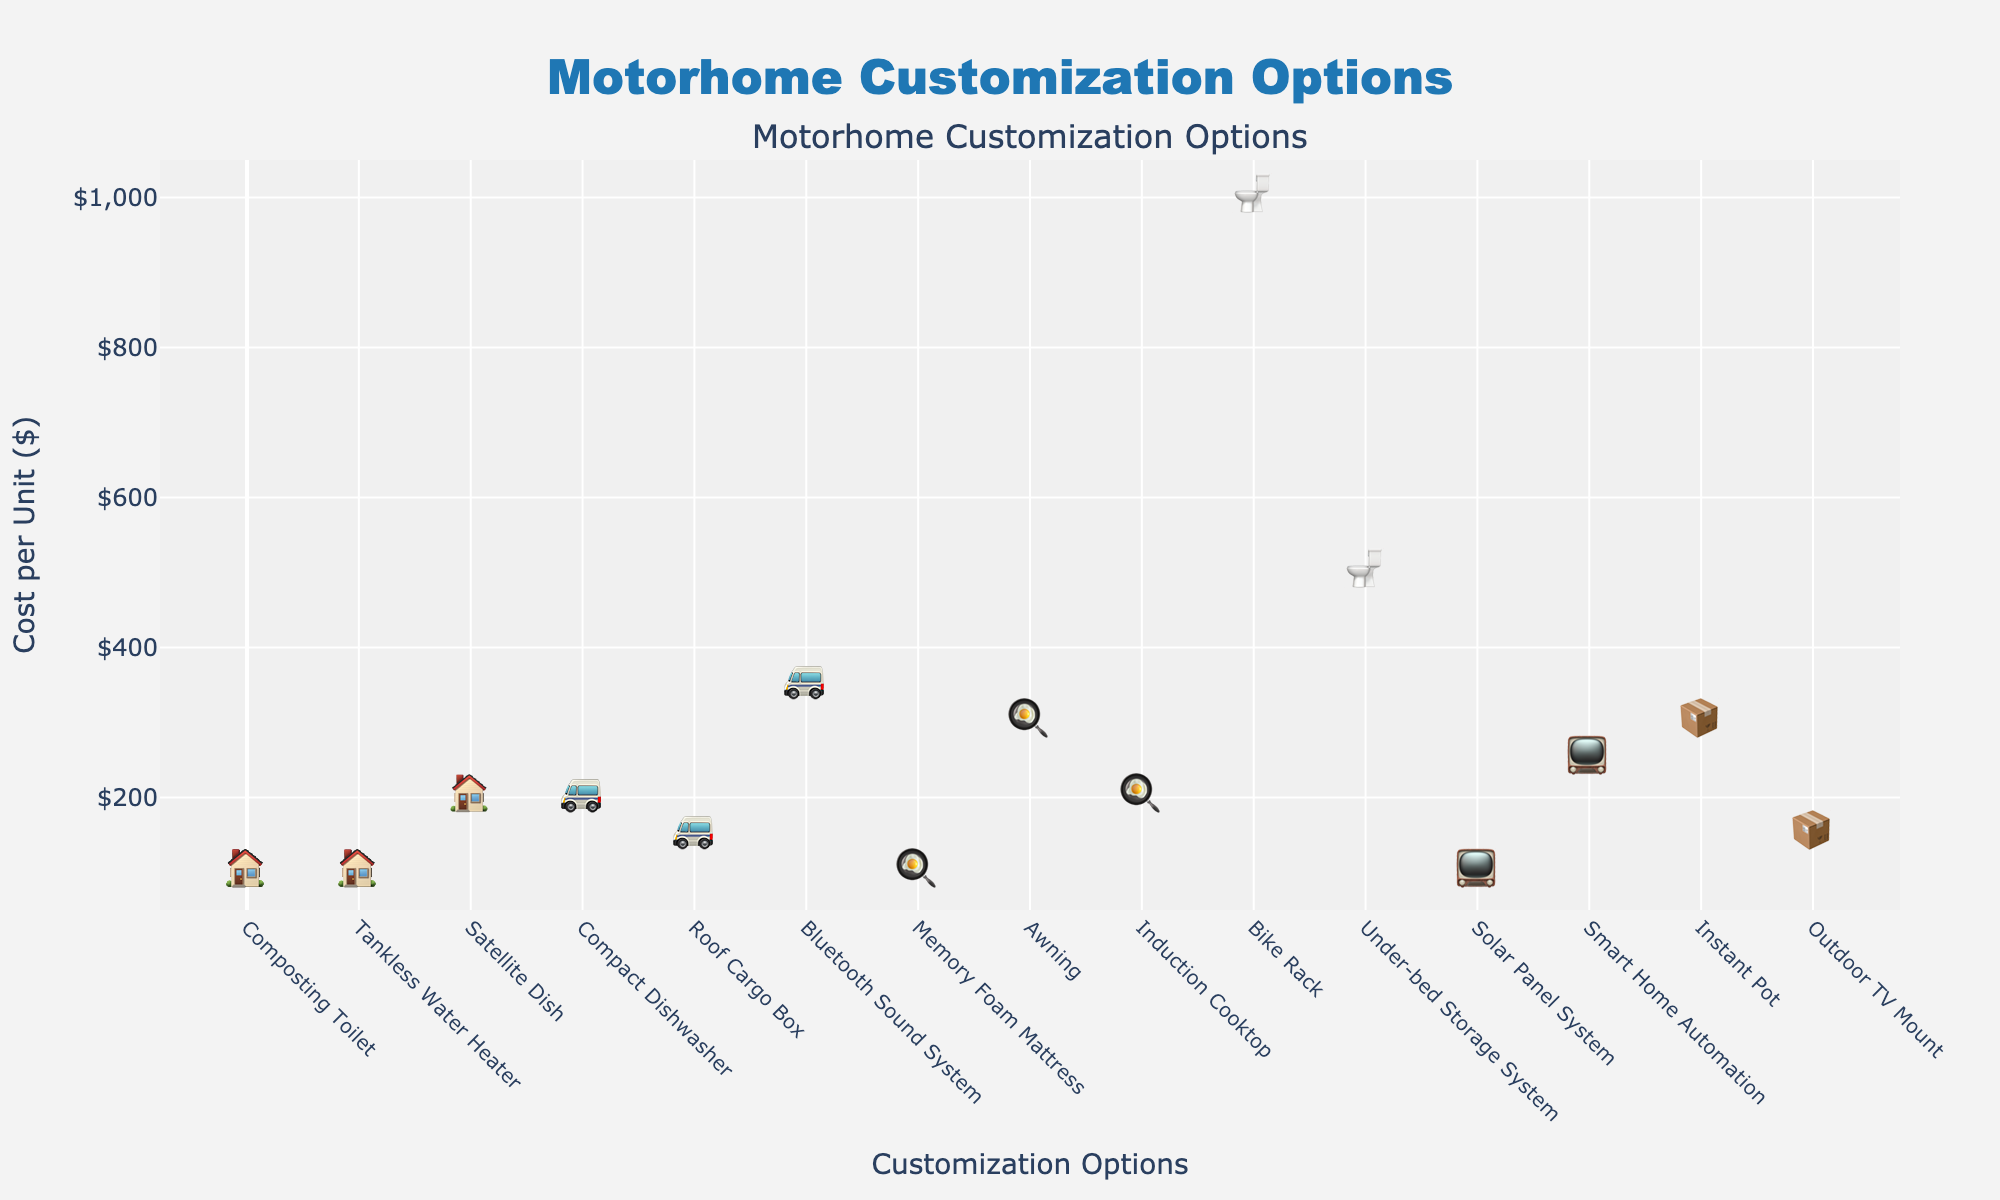Which customization option has the highest cost per unit? The highest cost per unit can be found by looking for the highest point on the y-axis, which represents cost per unit.
Answer: Composting Toilet What is the total cost of all Interior customizations? The total cost is obtained by summing the costs of all Interior customizations which are Solar Panel System ($500), Smart Home Automation ($300), and Memory Foam Mattress ($200). Adding them results in $500 + $300 + $200.
Answer: $1000 Which category has the least number of customization options? By counting the different categories, we find that Kitchen has fewer options compared to other categories like Interior or Exterior.
Answer: Kitchen How many units of Solar Panel System and Awning combined are represented in the plot? We count the units for both customizations: Solar Panel System (5 units) and Awning (2 units). Adding them together results in 5 + 2.
Answer: 7 Which customization option in the Kitchen category has the highest cost per unit? We compare the cost per unit for each Kitchen item: Instant Pot ($100), Compact Dishwasher ($300), and Induction Cooktop ($200). The Compact Dishwasher has the highest cost per unit.
Answer: Compact Dishwasher Between Tankless Water Heater and Bluetooth Sound System, which one has a lower cost per unit and what is the difference in cost per unit between them? Calculate the cost per unit: Tankless Water Heater ($500) and Bluetooth Sound System ($250). The difference is $500 - $250.
Answer: Bluetooth Sound System, $250 Which customization option has a cost exactly on the y-axis tick of $150? Look for points on the y-axis at the $150 mark. Only the Bike Rack fits this criterion.
Answer: Bike Rack How many customizations fall under the Exterior category, and what is their total cost? Exterior category includes Awning, Bike Rack, and Satellite Dish. Summing their costs ($400 + $150 + $350) gives the total cost.
Answer: 3, $900 